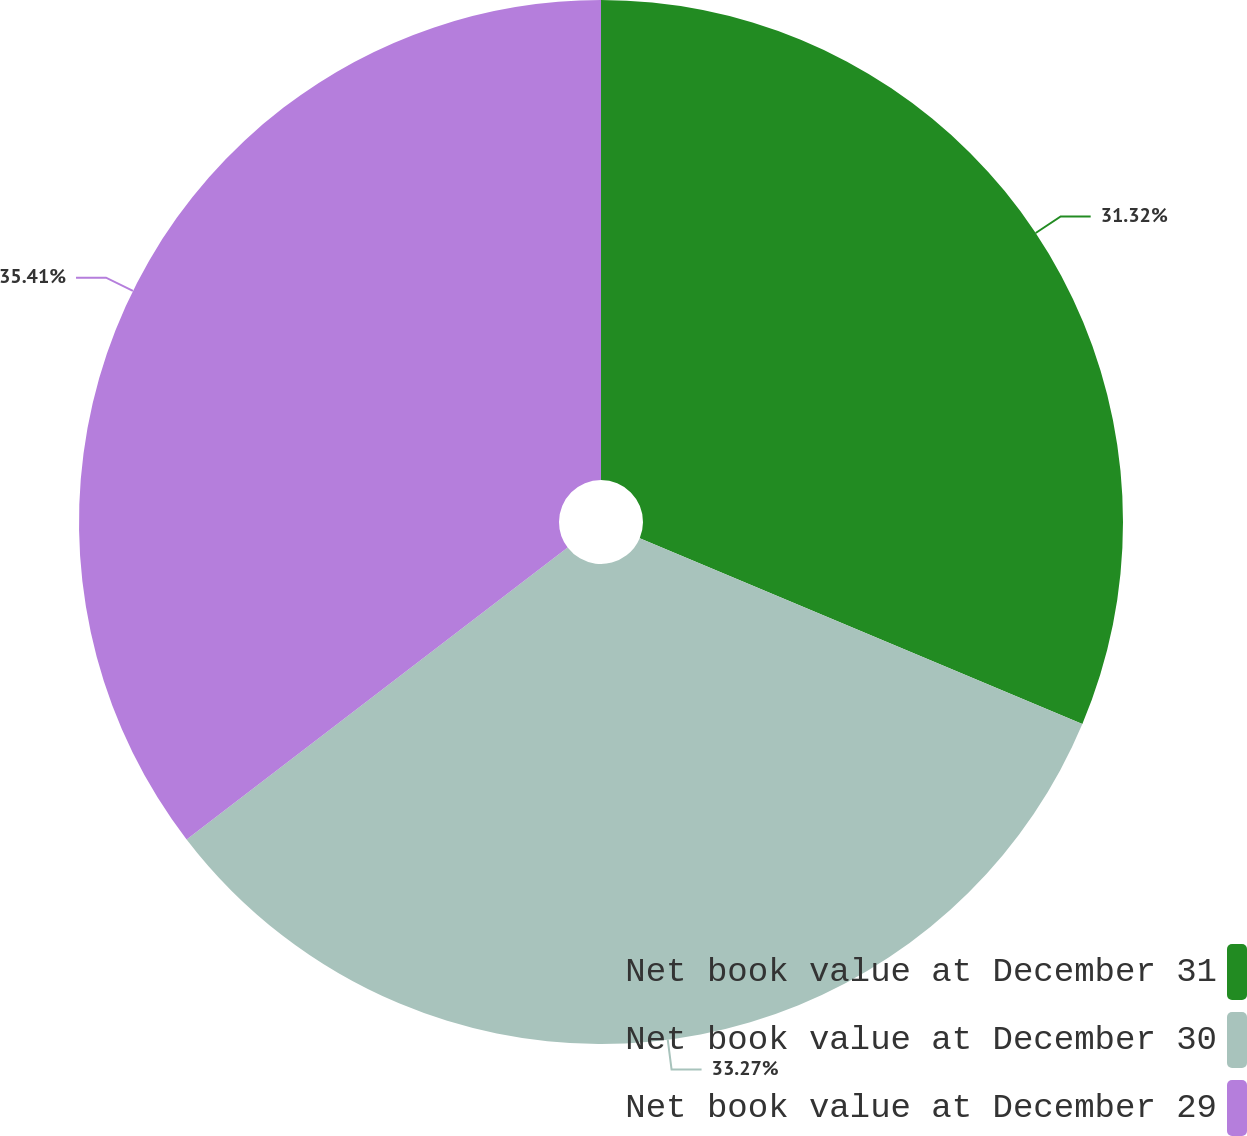Convert chart to OTSL. <chart><loc_0><loc_0><loc_500><loc_500><pie_chart><fcel>Net book value at December 31<fcel>Net book value at December 30<fcel>Net book value at December 29<nl><fcel>31.32%<fcel>33.27%<fcel>35.4%<nl></chart> 